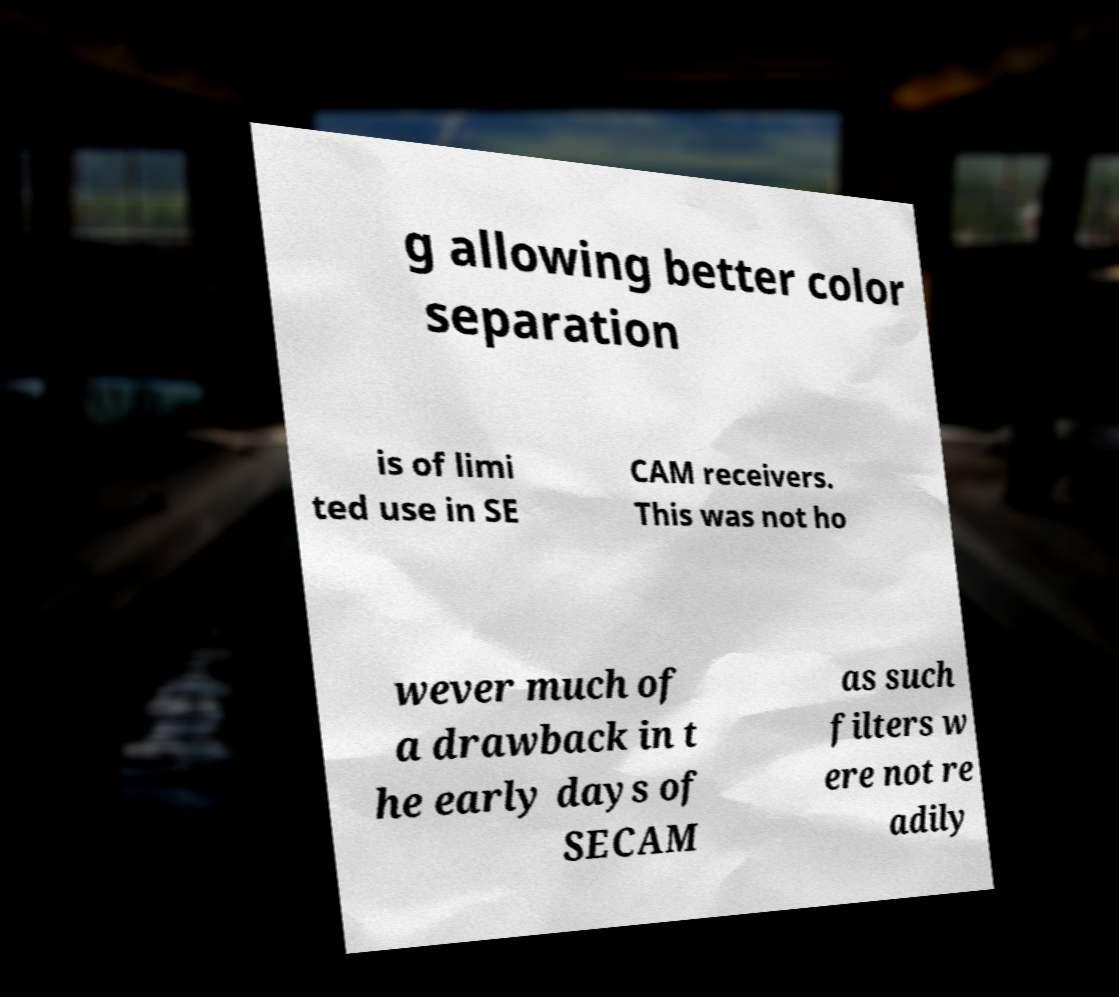For documentation purposes, I need the text within this image transcribed. Could you provide that? g allowing better color separation is of limi ted use in SE CAM receivers. This was not ho wever much of a drawback in t he early days of SECAM as such filters w ere not re adily 